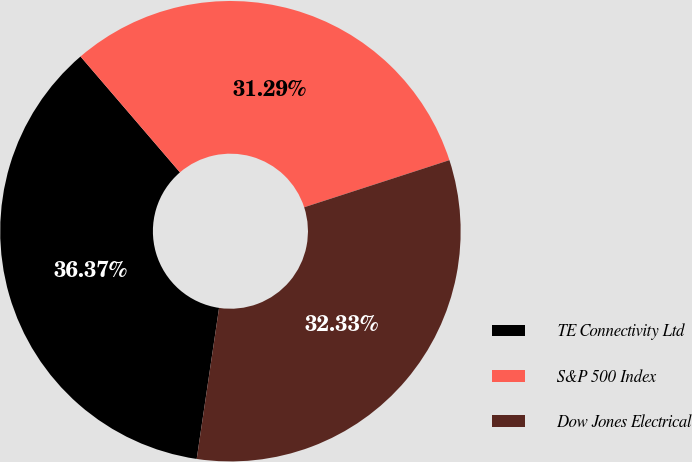Convert chart to OTSL. <chart><loc_0><loc_0><loc_500><loc_500><pie_chart><fcel>TE Connectivity Ltd<fcel>S&P 500 Index<fcel>Dow Jones Electrical<nl><fcel>36.37%<fcel>31.29%<fcel>32.33%<nl></chart> 